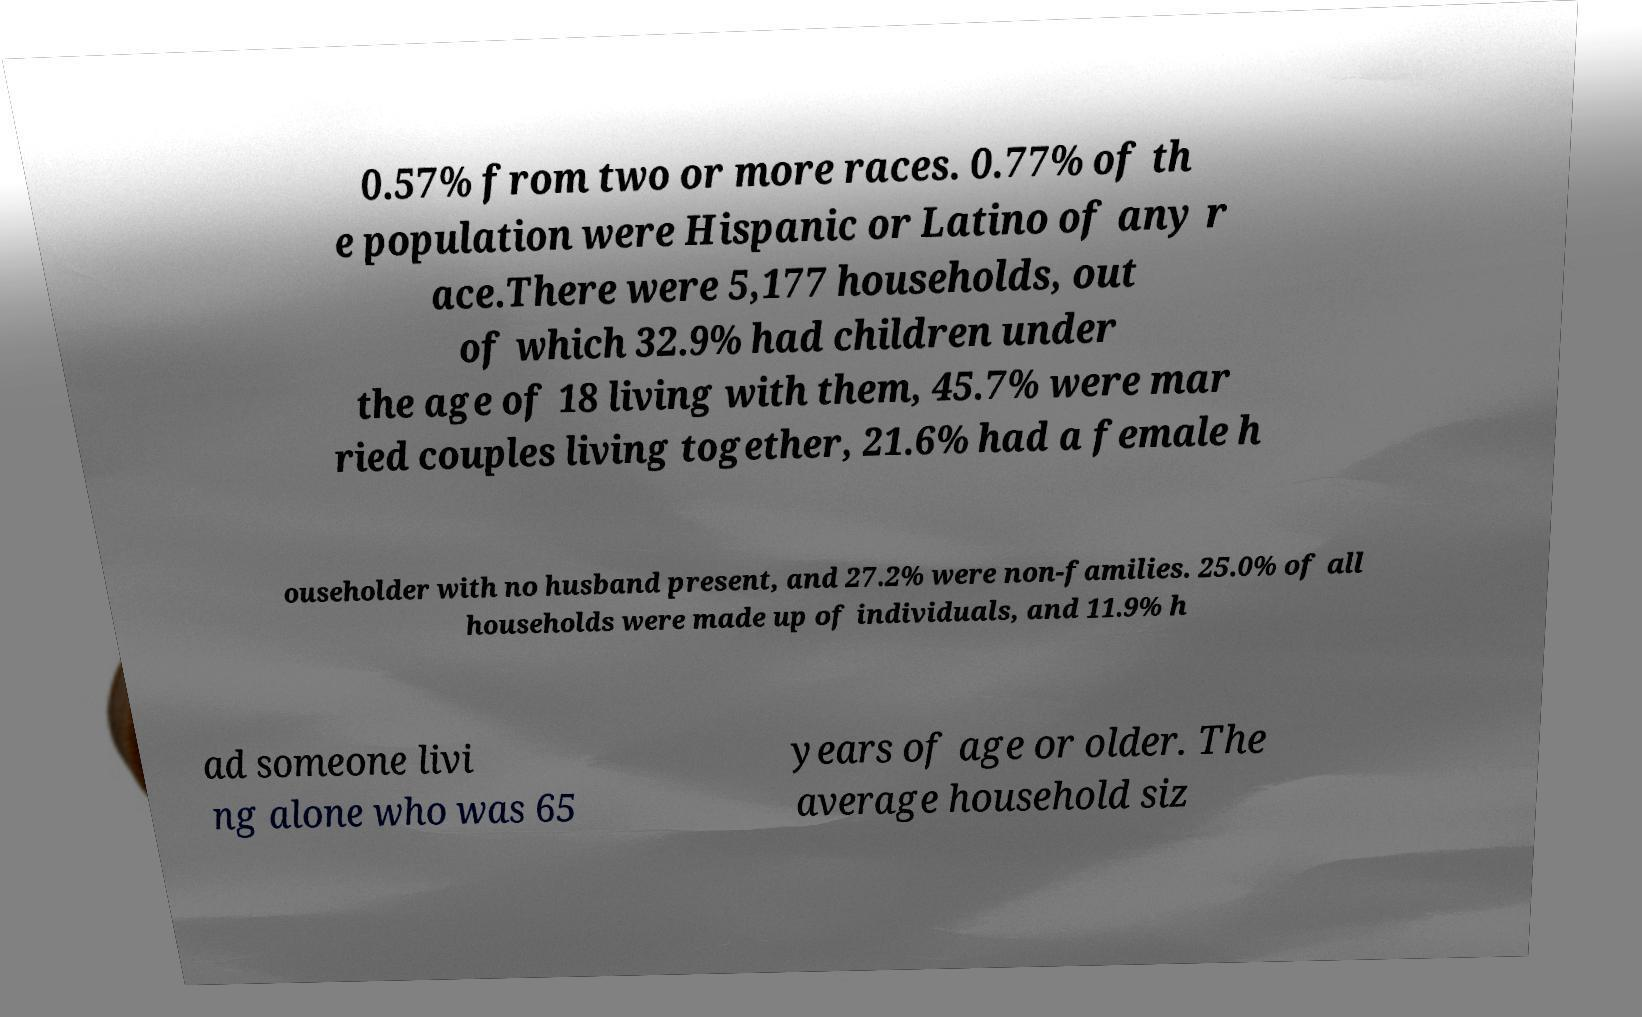Could you assist in decoding the text presented in this image and type it out clearly? 0.57% from two or more races. 0.77% of th e population were Hispanic or Latino of any r ace.There were 5,177 households, out of which 32.9% had children under the age of 18 living with them, 45.7% were mar ried couples living together, 21.6% had a female h ouseholder with no husband present, and 27.2% were non-families. 25.0% of all households were made up of individuals, and 11.9% h ad someone livi ng alone who was 65 years of age or older. The average household siz 